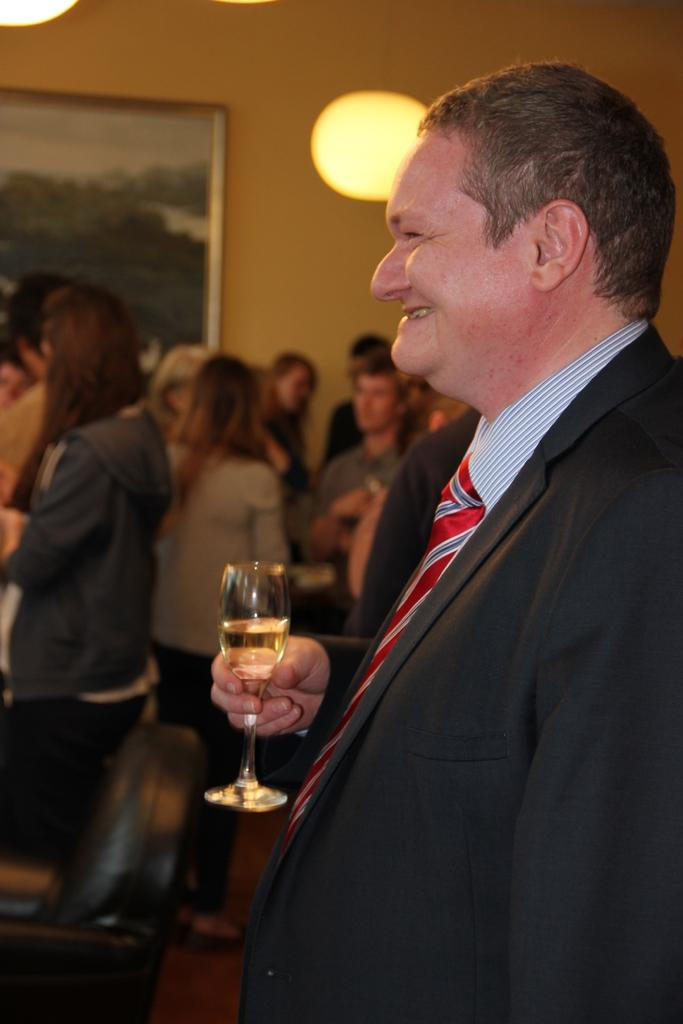How many people are present in the image? There are many people in the image. What is a person holding in their hand? A person is holding a wine glass in their hand. What can be seen on the wall in the image? There is a photo frame on the wall. Can you describe the lighting in the image? There is a light in the image. What type of watch is the person wearing on their knee in the image? There is no watch or person wearing a watch on their knee in the image. 